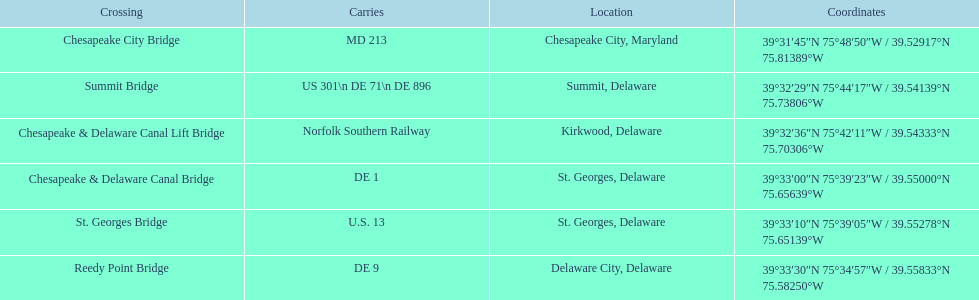In summit, delaware, which bridge can be found? Summit Bridge. 